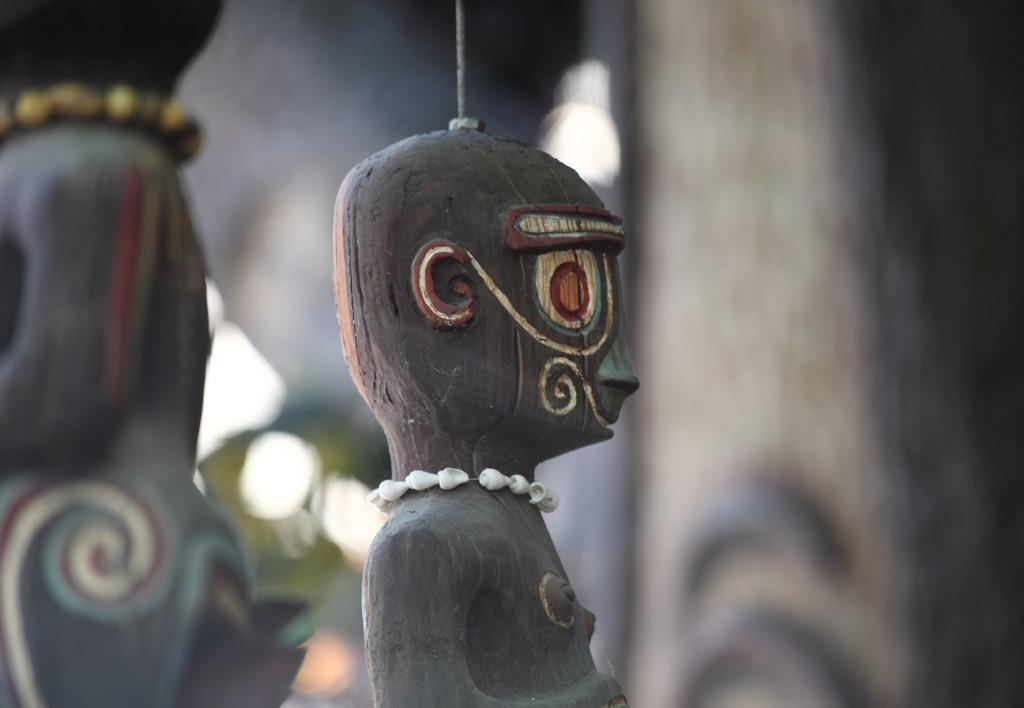What objects are present in the image? There are toys in the image. What colors are the toys? The toys are in brown and black color. Can you describe the background of the image? The background of the image is blurred. What type of quartz can be seen in the image? There is no quartz present in the image; it features toys in brown and black color. Can you tell me how many roses are in the image? There are no roses present in the image; it features toys in brown and black color. 